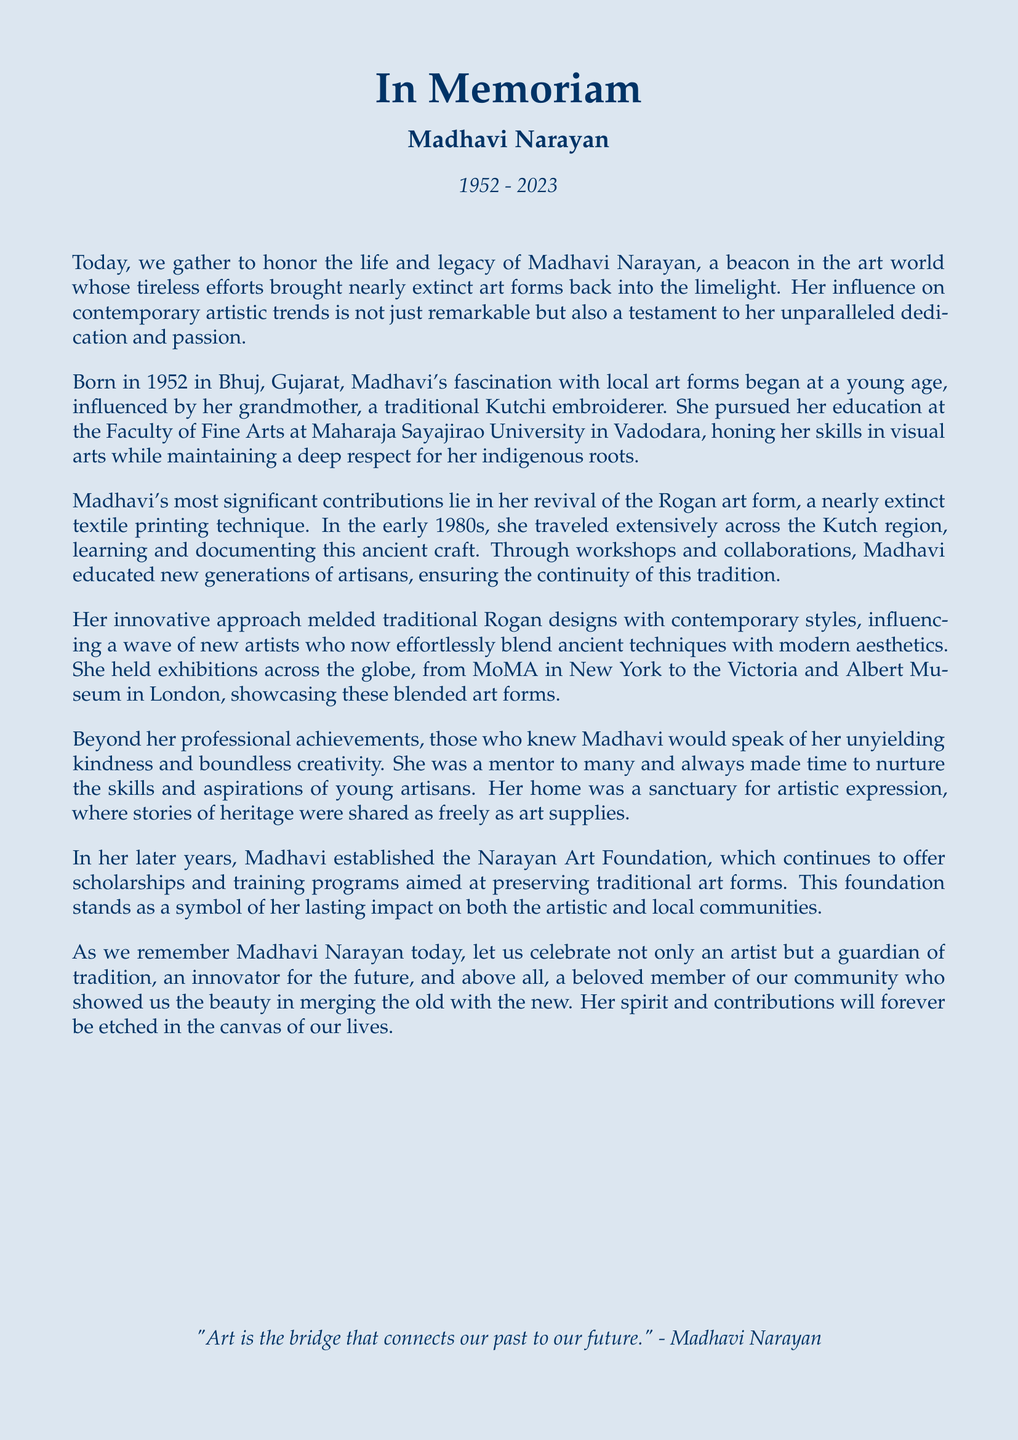What year was Madhavi Narayan born? The document explicitly states that Madhavi Narayan was born in 1952.
Answer: 1952 What art form did Madhavi revive? The text mentions that Madhavi's significant contribution was the revival of the Rogan art form.
Answer: Rogan Which university did Madhavi attend? The document indicates that she pursued her education at the Faculty of Fine Arts at Maharaja Sayajirao University.
Answer: Maharaja Sayajirao University What was the purpose of the Narayan Art Foundation? The document explains that the foundation offers scholarships and training programs aimed at preserving traditional art forms.
Answer: Preserving traditional art forms Which major museums hosted Madhavi's exhibitions? The text lists MoMA in New York and the Victoria and Albert Museum in London as venues for her exhibitions.
Answer: MoMA and Victoria and Albert Museum How did Madhavi influence contemporary artists? The document states she melded traditional Rogan designs with contemporary styles, influencing new artists.
Answer: Melding traditional and contemporary styles What role did Madhavi play in the community? The document describes her as a mentor to many and a beloved member of the community.
Answer: Mentor and beloved community member What was Madhavi's initial influence in art? The text implies that her initial influence in art came from her grandmother, a traditional Kutchi embroiderer.
Answer: Her grandmother In what region did Madhavi document the Rogan art form? The document mentions that she traveled extensively across the Kutch region.
Answer: Kutch region 